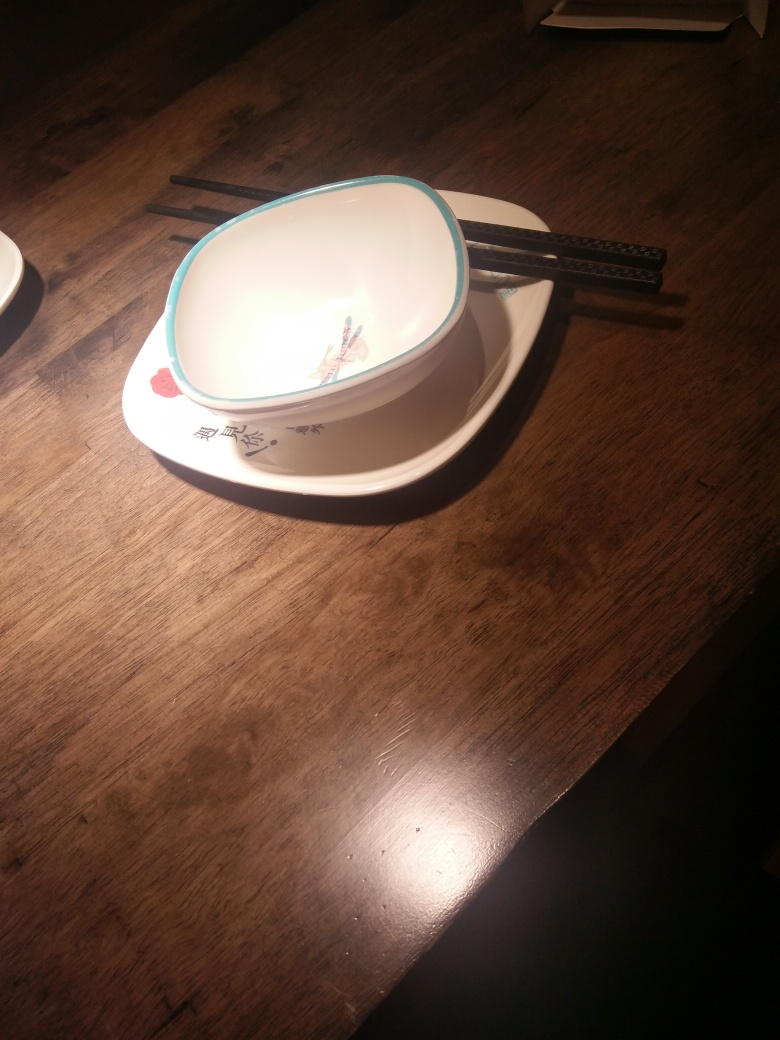What time of day does the lighting suggest? The warm yellowish cast of the light suggests an indoor setting, possibly evening or night time, when artificial lighting would be used to illuminate the scene. 